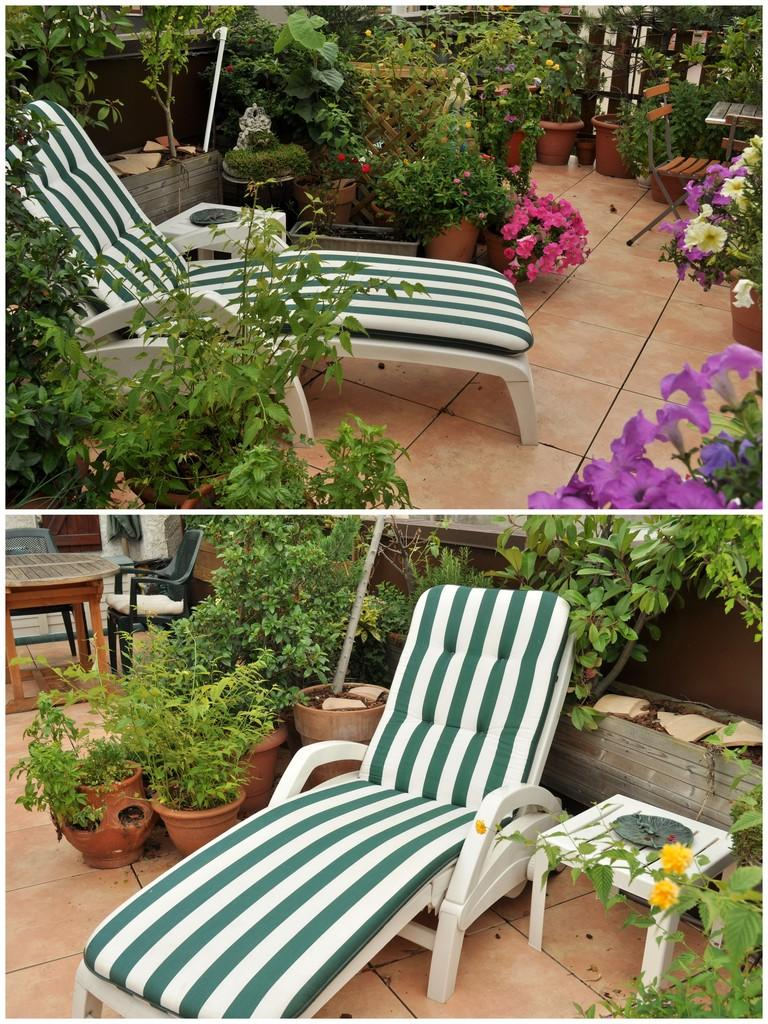What is the composition of the image? The image is a collage of similar pictures. Can you identify any specific objects in the image? Yes, there is a chair in the image. What type of natural elements are present in the image? There are plants around in the image. Can you see any rats running around in the image? There are no rats present in the image. What type of hair is visible on the chair in the image? There is no hair visible on the chair in the image. 